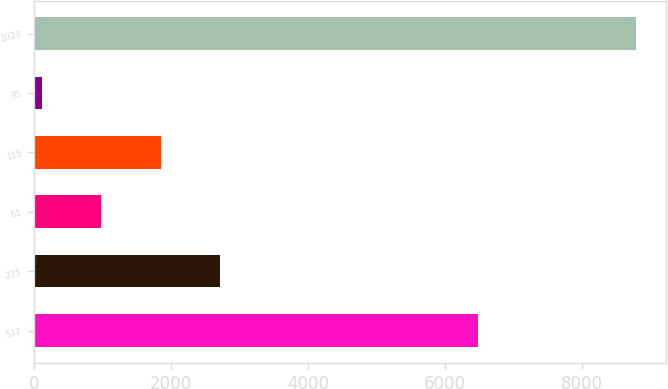Convert chart to OTSL. <chart><loc_0><loc_0><loc_500><loc_500><bar_chart><fcel>537<fcel>275<fcel>61<fcel>115<fcel>35<fcel>1023<nl><fcel>6487.2<fcel>2716.58<fcel>982.06<fcel>1849.32<fcel>114.8<fcel>8787.4<nl></chart> 